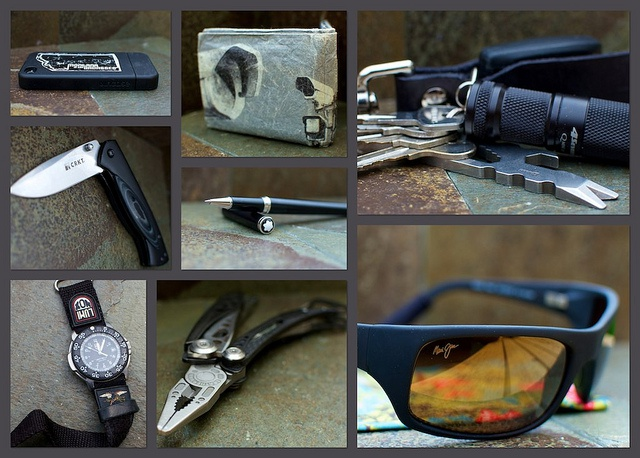Describe the objects in this image and their specific colors. I can see knife in black, white, and gray tones, cell phone in black, blue, gray, and navy tones, and clock in black, darkgray, lavender, and gray tones in this image. 